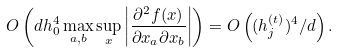Convert formula to latex. <formula><loc_0><loc_0><loc_500><loc_500>O \left ( d h _ { 0 } ^ { 4 } \max _ { a , b } \sup _ { x } \left | \frac { \partial ^ { 2 } f ( x ) } { \partial x _ { a } \partial x _ { b } } \right | \right ) = O \left ( ( h _ { j } ^ { ( t ) } ) ^ { 4 } / d \right ) .</formula> 